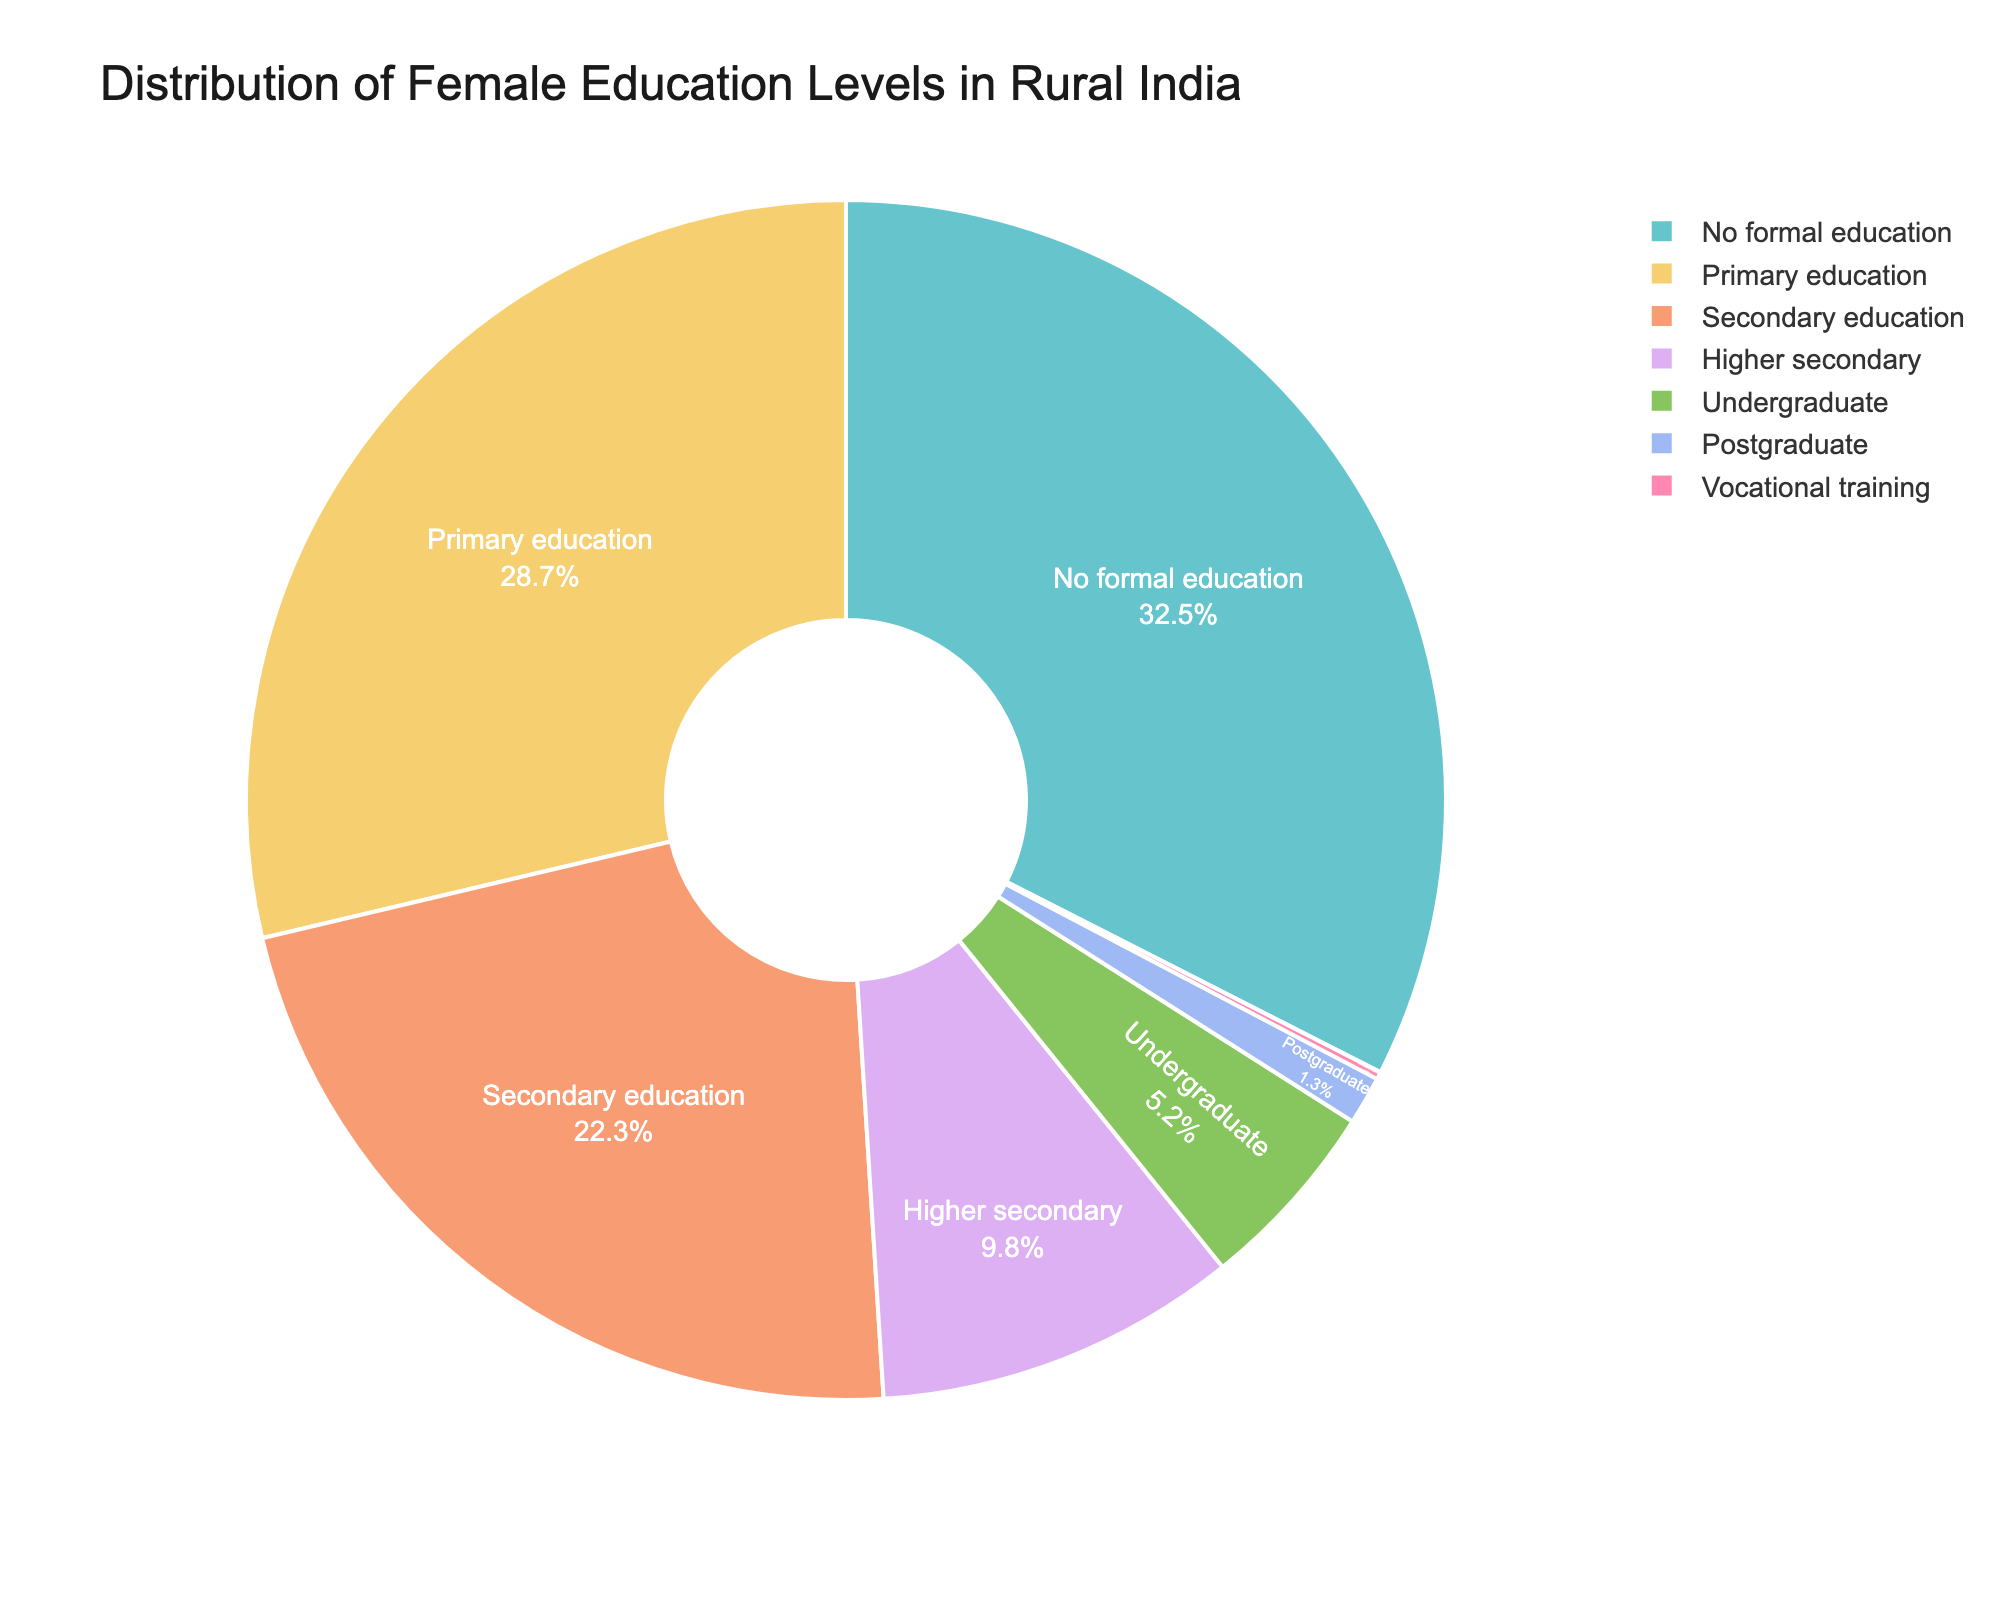Which education level has the highest percentage of females? The "No formal education" slice has the largest area in the pie chart, which indicates it has the highest percentage of females.
Answer: No formal education What is the combined percentage of females with secondary and primary education levels? The percentages for primary education and secondary education are 28.7% and 22.3% respectively. Adding them together gives 28.7% + 22.3% = 51%.
Answer: 51% Which education levels contribute less than 10% each to the overall distribution? The slices for "Higher secondary" (9.8%), "Undergraduate" (5.2%), "Postgraduate" (1.3%), and "Vocational training" (0.2%) are each less than 10%.
Answer: Higher secondary, Undergraduate, Postgraduate, Vocational training How does the percentage of females with no formal education compare to those with higher secondary education? The percentage of females with no formal education (32.5%) is much higher than that of females with higher secondary education (9.8%).
Answer: No formal education > Higher secondary Which two education levels taken together are equal to the percentage of females with no formal education? The sum of the percentages for primary education (28.7%) and vocational training (0.2%) gives 28.7% + 0.2% = 28.9%. Combining this with the percentage for secondary education (22.3%) gives approximately 51.2%, but to match closer to 32.5%, only the slices for secondary education (22.3%) and higher secondary education (9.8%) add up to approximately reach the percentage for no formal education. 22.3% + 9.8% = 32.1%.
Answer: Secondary education and Higher secondary Which education level has the lowest percentage of females? The "Vocational training" slice has the smallest area in the pie chart, indicating it has the lowest percentage of females.
Answer: Vocational training What is the difference in percentage between female undergraduate and postgraduate education levels? The percentage of females with undergraduate education is 5.2%, and with postgraduate education is 1.3%. The difference is 5.2% - 1.3% = 3.9%.
Answer: 3.9% How does the percentage of females with higher secondary education compare visually to those with primary education? The slice for "Primary education" is visually larger than the slice for "Higher secondary," indicating a higher percentage for primary education.
Answer: Primary education > Higher secondary Which education level has a percentage closest to one-fourth of the whole distribution? The percentage closest to one-fourth (25%) is "Primary education" at 28.7%.
Answer: Primary education 